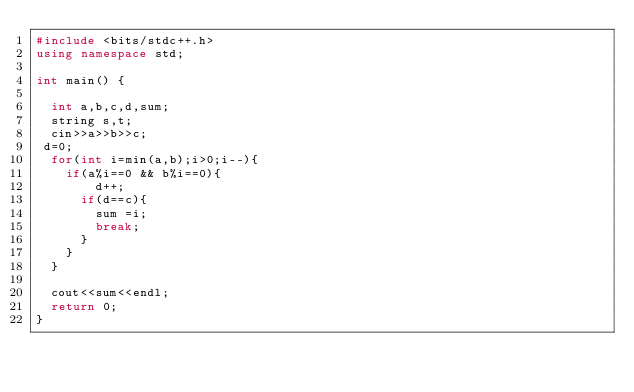Convert code to text. <code><loc_0><loc_0><loc_500><loc_500><_C++_>#include <bits/stdc++.h>
using namespace std;

int main() {

  int a,b,c,d,sum;
  string s,t;
  cin>>a>>b>>c;
 d=0;
  for(int i=min(a,b);i>0;i--){
  	if(a%i==0 && b%i==0){
    	d++;
      if(d==c){
      	sum =i;
        break;
      }
    }
  }
  
  cout<<sum<<endl;
  return 0;
}
</code> 